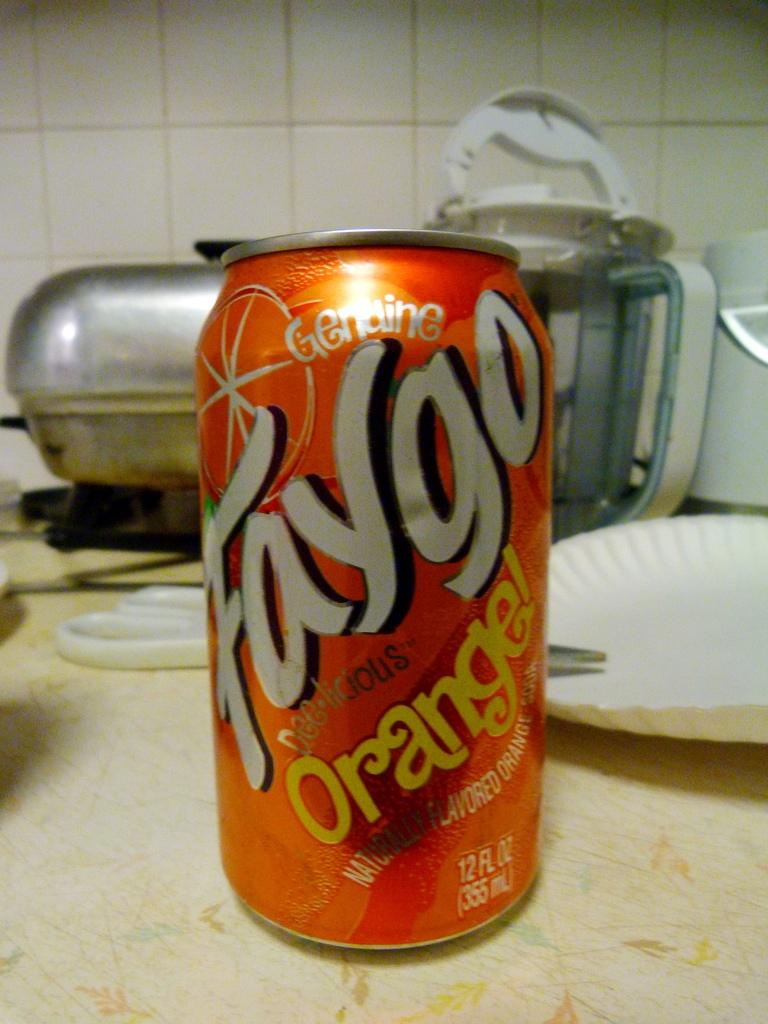<image>
Provide a brief description of the given image. The orange flavored drink sits on a messy kitchen bench. 